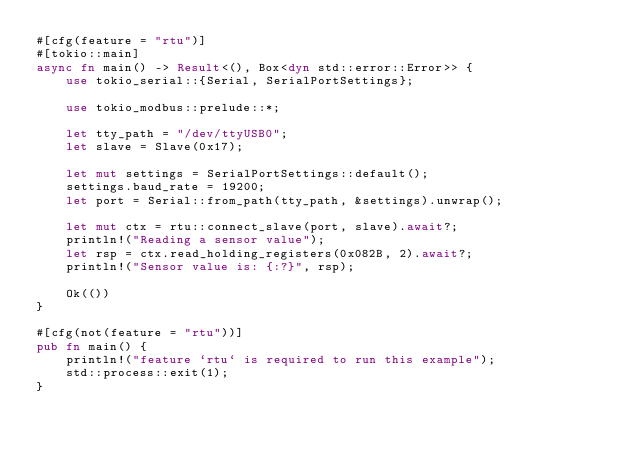Convert code to text. <code><loc_0><loc_0><loc_500><loc_500><_Rust_>#[cfg(feature = "rtu")]
#[tokio::main]
async fn main() -> Result<(), Box<dyn std::error::Error>> {
    use tokio_serial::{Serial, SerialPortSettings};

    use tokio_modbus::prelude::*;

    let tty_path = "/dev/ttyUSB0";
    let slave = Slave(0x17);

    let mut settings = SerialPortSettings::default();
    settings.baud_rate = 19200;
    let port = Serial::from_path(tty_path, &settings).unwrap();

    let mut ctx = rtu::connect_slave(port, slave).await?;
    println!("Reading a sensor value");
    let rsp = ctx.read_holding_registers(0x082B, 2).await?;
    println!("Sensor value is: {:?}", rsp);

    Ok(())
}

#[cfg(not(feature = "rtu"))]
pub fn main() {
    println!("feature `rtu` is required to run this example");
    std::process::exit(1);
}
</code> 